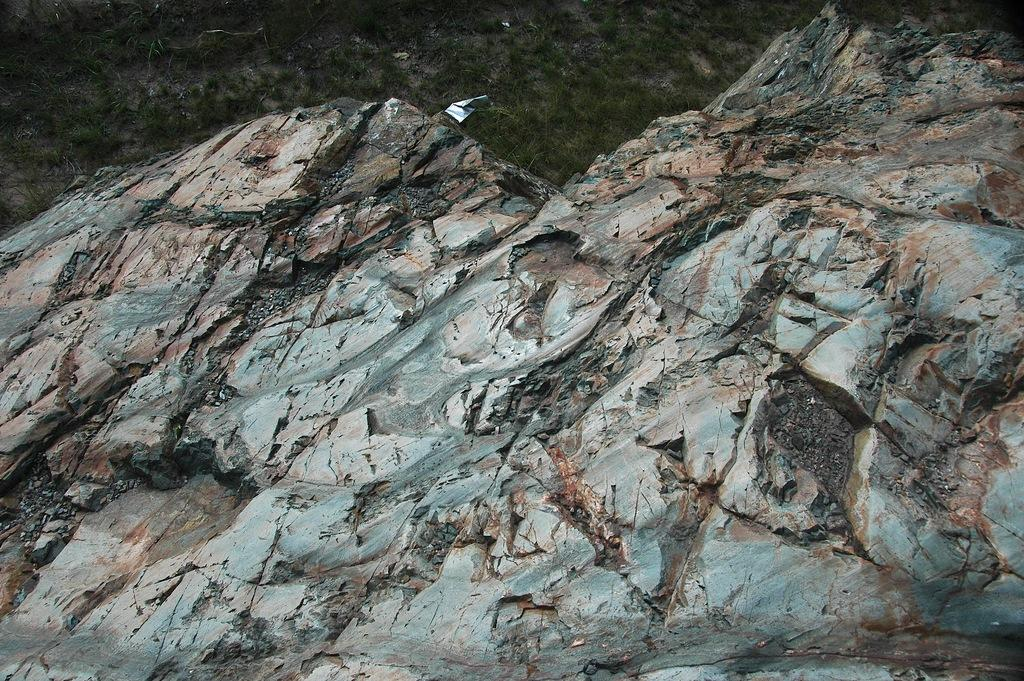What type of surface can be seen in the image? There is a rock surface and a grass surface with plants in the image. What kind of vegetation is present on the grass surface? The grass surface has plants on it. How many chickens are visible on the rock surface in the image? There are no chickens present in the image. What type of wall can be seen in the image? There is no wall present in the image. 